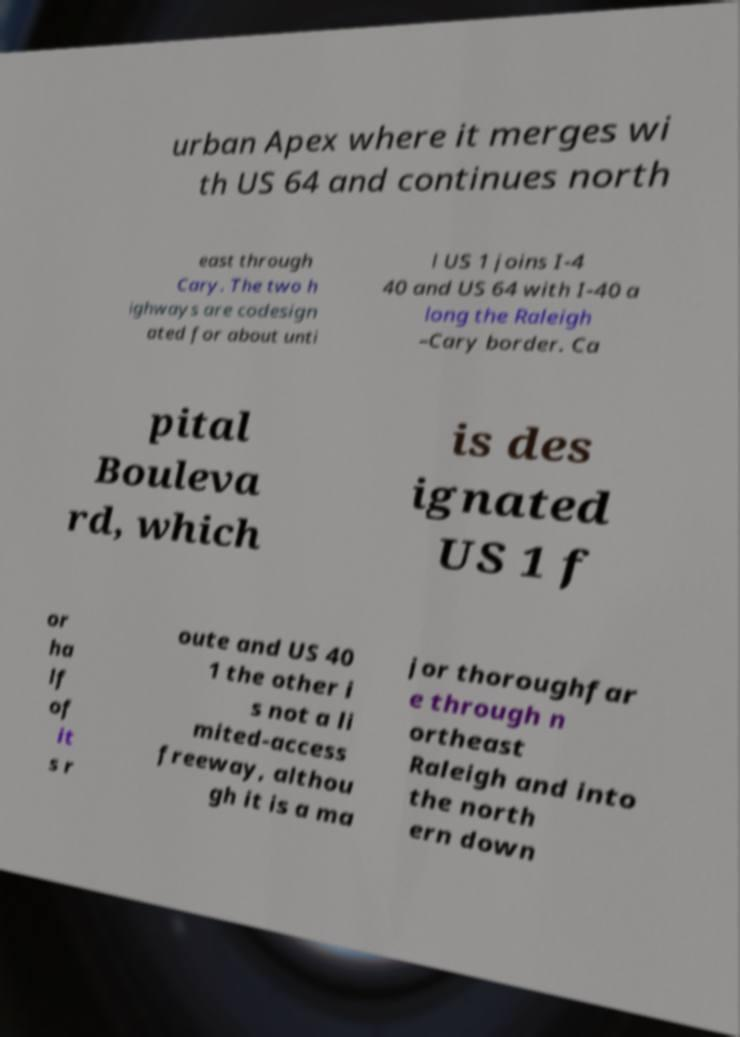Please read and relay the text visible in this image. What does it say? urban Apex where it merges wi th US 64 and continues north east through Cary. The two h ighways are codesign ated for about unti l US 1 joins I-4 40 and US 64 with I-40 a long the Raleigh –Cary border. Ca pital Bouleva rd, which is des ignated US 1 f or ha lf of it s r oute and US 40 1 the other i s not a li mited-access freeway, althou gh it is a ma jor thoroughfar e through n ortheast Raleigh and into the north ern down 